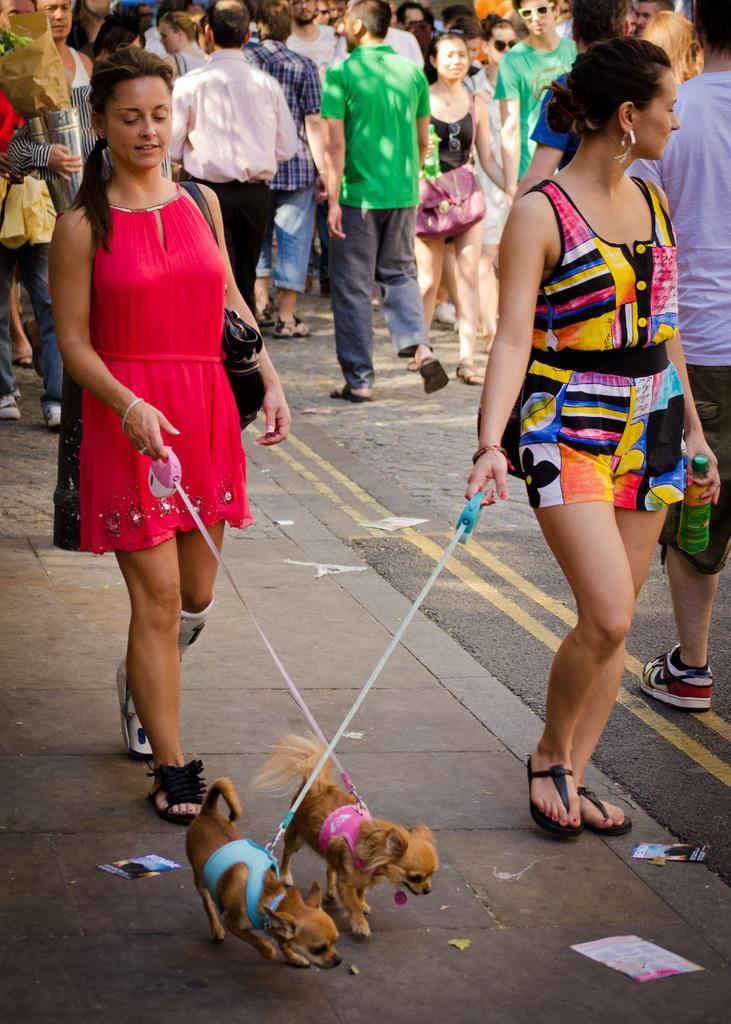In one or two sentences, can you explain what this image depicts? This image is clicked outside. There are so many people on the top who are walking. In the middle there are two people who are holding dogs. Both of them women. The one who is on the right side is holding a bottle, the one who is on the left side is hanging bag to her shoulder. 